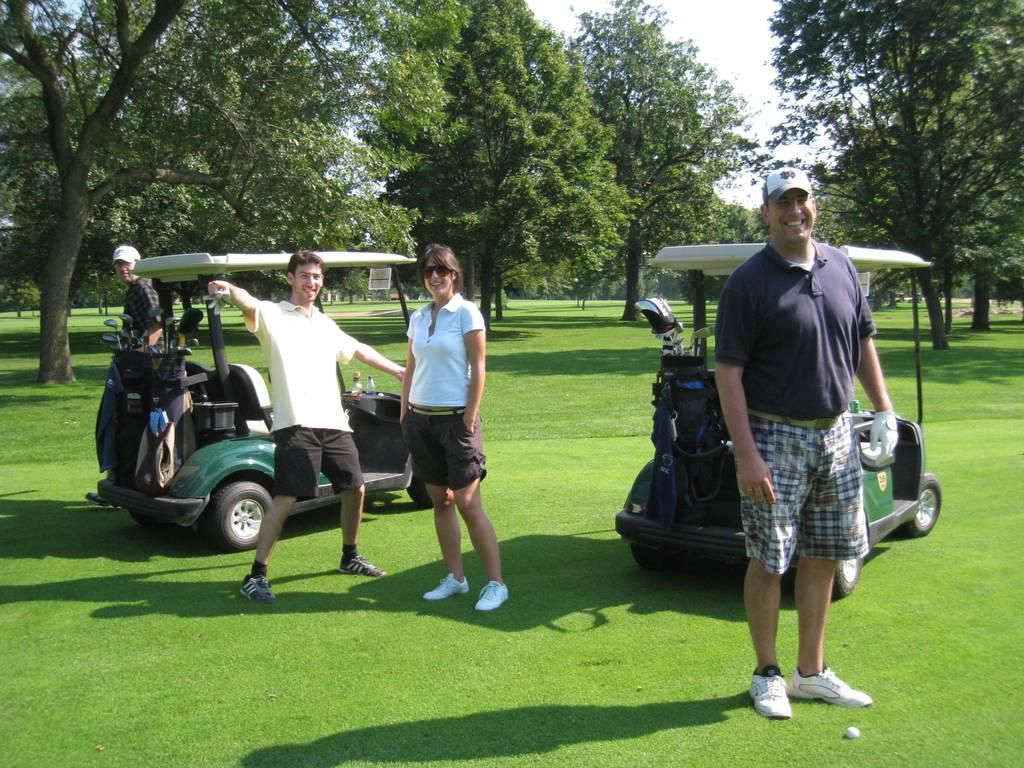How many people are standing on the grass in the image? There are four persons standing on the grass in the image. What else can be seen in the image besides the people? There are vehicles and bottles visible in the image. What can be seen in the background of the image? There are trees and the sky visible in the background of the image. What type of drum is being played by one of the persons in the image? There is no drum present in the image; only the four persons, vehicles, bottles, trees, and the sky are visible. 